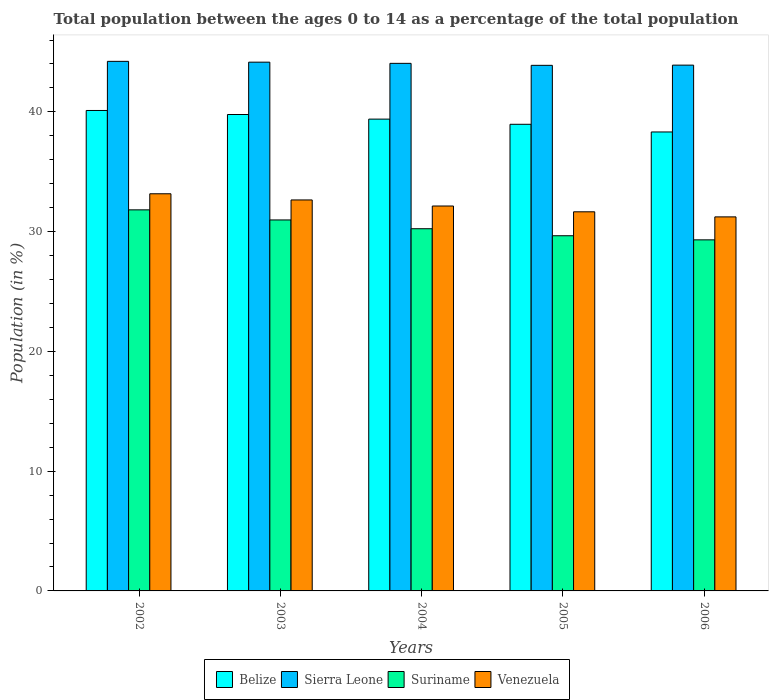How many groups of bars are there?
Give a very brief answer. 5. Are the number of bars on each tick of the X-axis equal?
Offer a very short reply. Yes. How many bars are there on the 1st tick from the right?
Ensure brevity in your answer.  4. What is the percentage of the population ages 0 to 14 in Venezuela in 2005?
Offer a very short reply. 31.66. Across all years, what is the maximum percentage of the population ages 0 to 14 in Venezuela?
Make the answer very short. 33.16. Across all years, what is the minimum percentage of the population ages 0 to 14 in Sierra Leone?
Ensure brevity in your answer.  43.89. In which year was the percentage of the population ages 0 to 14 in Venezuela maximum?
Your response must be concise. 2002. What is the total percentage of the population ages 0 to 14 in Sierra Leone in the graph?
Give a very brief answer. 220.22. What is the difference between the percentage of the population ages 0 to 14 in Sierra Leone in 2003 and that in 2004?
Give a very brief answer. 0.1. What is the difference between the percentage of the population ages 0 to 14 in Venezuela in 2003 and the percentage of the population ages 0 to 14 in Sierra Leone in 2002?
Give a very brief answer. -11.57. What is the average percentage of the population ages 0 to 14 in Suriname per year?
Make the answer very short. 30.4. In the year 2004, what is the difference between the percentage of the population ages 0 to 14 in Sierra Leone and percentage of the population ages 0 to 14 in Venezuela?
Give a very brief answer. 11.91. What is the ratio of the percentage of the population ages 0 to 14 in Venezuela in 2003 to that in 2005?
Ensure brevity in your answer.  1.03. What is the difference between the highest and the second highest percentage of the population ages 0 to 14 in Suriname?
Your answer should be compact. 0.84. What is the difference between the highest and the lowest percentage of the population ages 0 to 14 in Suriname?
Your answer should be compact. 2.5. In how many years, is the percentage of the population ages 0 to 14 in Suriname greater than the average percentage of the population ages 0 to 14 in Suriname taken over all years?
Your answer should be compact. 2. Is the sum of the percentage of the population ages 0 to 14 in Belize in 2002 and 2003 greater than the maximum percentage of the population ages 0 to 14 in Suriname across all years?
Your response must be concise. Yes. Is it the case that in every year, the sum of the percentage of the population ages 0 to 14 in Venezuela and percentage of the population ages 0 to 14 in Suriname is greater than the sum of percentage of the population ages 0 to 14 in Belize and percentage of the population ages 0 to 14 in Sierra Leone?
Offer a very short reply. No. What does the 2nd bar from the left in 2005 represents?
Offer a terse response. Sierra Leone. What does the 3rd bar from the right in 2003 represents?
Offer a very short reply. Sierra Leone. Are all the bars in the graph horizontal?
Offer a terse response. No. How many years are there in the graph?
Offer a terse response. 5. Where does the legend appear in the graph?
Provide a short and direct response. Bottom center. What is the title of the graph?
Your answer should be compact. Total population between the ages 0 to 14 as a percentage of the total population. Does "Hong Kong" appear as one of the legend labels in the graph?
Your answer should be compact. No. What is the Population (in %) in Belize in 2002?
Your answer should be very brief. 40.12. What is the Population (in %) of Sierra Leone in 2002?
Keep it short and to the point. 44.22. What is the Population (in %) of Suriname in 2002?
Your answer should be very brief. 31.82. What is the Population (in %) in Venezuela in 2002?
Your answer should be very brief. 33.16. What is the Population (in %) in Belize in 2003?
Give a very brief answer. 39.78. What is the Population (in %) in Sierra Leone in 2003?
Make the answer very short. 44.15. What is the Population (in %) in Suriname in 2003?
Make the answer very short. 30.98. What is the Population (in %) of Venezuela in 2003?
Provide a short and direct response. 32.65. What is the Population (in %) in Belize in 2004?
Provide a short and direct response. 39.4. What is the Population (in %) of Sierra Leone in 2004?
Ensure brevity in your answer.  44.05. What is the Population (in %) in Suriname in 2004?
Provide a succinct answer. 30.24. What is the Population (in %) of Venezuela in 2004?
Your answer should be compact. 32.14. What is the Population (in %) of Belize in 2005?
Give a very brief answer. 38.97. What is the Population (in %) of Sierra Leone in 2005?
Offer a very short reply. 43.89. What is the Population (in %) of Suriname in 2005?
Keep it short and to the point. 29.66. What is the Population (in %) of Venezuela in 2005?
Ensure brevity in your answer.  31.66. What is the Population (in %) in Belize in 2006?
Your answer should be compact. 38.32. What is the Population (in %) in Sierra Leone in 2006?
Provide a short and direct response. 43.9. What is the Population (in %) of Suriname in 2006?
Ensure brevity in your answer.  29.32. What is the Population (in %) of Venezuela in 2006?
Your answer should be compact. 31.23. Across all years, what is the maximum Population (in %) of Belize?
Your answer should be very brief. 40.12. Across all years, what is the maximum Population (in %) of Sierra Leone?
Your response must be concise. 44.22. Across all years, what is the maximum Population (in %) of Suriname?
Your response must be concise. 31.82. Across all years, what is the maximum Population (in %) of Venezuela?
Offer a terse response. 33.16. Across all years, what is the minimum Population (in %) in Belize?
Keep it short and to the point. 38.32. Across all years, what is the minimum Population (in %) in Sierra Leone?
Offer a terse response. 43.89. Across all years, what is the minimum Population (in %) in Suriname?
Your answer should be very brief. 29.32. Across all years, what is the minimum Population (in %) of Venezuela?
Offer a very short reply. 31.23. What is the total Population (in %) in Belize in the graph?
Make the answer very short. 196.59. What is the total Population (in %) of Sierra Leone in the graph?
Give a very brief answer. 220.22. What is the total Population (in %) of Suriname in the graph?
Provide a succinct answer. 152.02. What is the total Population (in %) in Venezuela in the graph?
Provide a short and direct response. 160.85. What is the difference between the Population (in %) in Belize in 2002 and that in 2003?
Provide a succinct answer. 0.34. What is the difference between the Population (in %) in Sierra Leone in 2002 and that in 2003?
Keep it short and to the point. 0.07. What is the difference between the Population (in %) in Suriname in 2002 and that in 2003?
Your answer should be compact. 0.84. What is the difference between the Population (in %) in Venezuela in 2002 and that in 2003?
Your response must be concise. 0.52. What is the difference between the Population (in %) in Belize in 2002 and that in 2004?
Keep it short and to the point. 0.72. What is the difference between the Population (in %) of Sierra Leone in 2002 and that in 2004?
Ensure brevity in your answer.  0.17. What is the difference between the Population (in %) of Suriname in 2002 and that in 2004?
Give a very brief answer. 1.58. What is the difference between the Population (in %) in Venezuela in 2002 and that in 2004?
Your answer should be very brief. 1.02. What is the difference between the Population (in %) in Belize in 2002 and that in 2005?
Your response must be concise. 1.15. What is the difference between the Population (in %) of Sierra Leone in 2002 and that in 2005?
Provide a succinct answer. 0.33. What is the difference between the Population (in %) in Suriname in 2002 and that in 2005?
Offer a very short reply. 2.16. What is the difference between the Population (in %) in Venezuela in 2002 and that in 2005?
Ensure brevity in your answer.  1.51. What is the difference between the Population (in %) of Belize in 2002 and that in 2006?
Your answer should be compact. 1.79. What is the difference between the Population (in %) of Sierra Leone in 2002 and that in 2006?
Offer a terse response. 0.32. What is the difference between the Population (in %) of Suriname in 2002 and that in 2006?
Provide a succinct answer. 2.5. What is the difference between the Population (in %) of Venezuela in 2002 and that in 2006?
Your response must be concise. 1.93. What is the difference between the Population (in %) of Belize in 2003 and that in 2004?
Provide a succinct answer. 0.39. What is the difference between the Population (in %) in Sierra Leone in 2003 and that in 2004?
Offer a very short reply. 0.1. What is the difference between the Population (in %) of Suriname in 2003 and that in 2004?
Ensure brevity in your answer.  0.73. What is the difference between the Population (in %) in Venezuela in 2003 and that in 2004?
Keep it short and to the point. 0.51. What is the difference between the Population (in %) of Belize in 2003 and that in 2005?
Your answer should be compact. 0.82. What is the difference between the Population (in %) of Sierra Leone in 2003 and that in 2005?
Provide a short and direct response. 0.26. What is the difference between the Population (in %) of Suriname in 2003 and that in 2005?
Ensure brevity in your answer.  1.32. What is the difference between the Population (in %) of Venezuela in 2003 and that in 2005?
Your response must be concise. 0.99. What is the difference between the Population (in %) in Belize in 2003 and that in 2006?
Give a very brief answer. 1.46. What is the difference between the Population (in %) of Sierra Leone in 2003 and that in 2006?
Make the answer very short. 0.25. What is the difference between the Population (in %) in Suriname in 2003 and that in 2006?
Make the answer very short. 1.66. What is the difference between the Population (in %) in Venezuela in 2003 and that in 2006?
Your answer should be very brief. 1.41. What is the difference between the Population (in %) in Belize in 2004 and that in 2005?
Your answer should be very brief. 0.43. What is the difference between the Population (in %) of Sierra Leone in 2004 and that in 2005?
Make the answer very short. 0.17. What is the difference between the Population (in %) in Suriname in 2004 and that in 2005?
Offer a terse response. 0.59. What is the difference between the Population (in %) in Venezuela in 2004 and that in 2005?
Keep it short and to the point. 0.48. What is the difference between the Population (in %) in Belize in 2004 and that in 2006?
Your answer should be very brief. 1.07. What is the difference between the Population (in %) of Sierra Leone in 2004 and that in 2006?
Offer a terse response. 0.15. What is the difference between the Population (in %) in Suriname in 2004 and that in 2006?
Ensure brevity in your answer.  0.93. What is the difference between the Population (in %) of Venezuela in 2004 and that in 2006?
Offer a very short reply. 0.91. What is the difference between the Population (in %) in Belize in 2005 and that in 2006?
Provide a short and direct response. 0.64. What is the difference between the Population (in %) in Sierra Leone in 2005 and that in 2006?
Give a very brief answer. -0.02. What is the difference between the Population (in %) in Suriname in 2005 and that in 2006?
Provide a succinct answer. 0.34. What is the difference between the Population (in %) of Venezuela in 2005 and that in 2006?
Offer a very short reply. 0.42. What is the difference between the Population (in %) of Belize in 2002 and the Population (in %) of Sierra Leone in 2003?
Offer a very short reply. -4.03. What is the difference between the Population (in %) in Belize in 2002 and the Population (in %) in Suriname in 2003?
Provide a short and direct response. 9.14. What is the difference between the Population (in %) of Belize in 2002 and the Population (in %) of Venezuela in 2003?
Make the answer very short. 7.47. What is the difference between the Population (in %) of Sierra Leone in 2002 and the Population (in %) of Suriname in 2003?
Your response must be concise. 13.24. What is the difference between the Population (in %) of Sierra Leone in 2002 and the Population (in %) of Venezuela in 2003?
Offer a terse response. 11.57. What is the difference between the Population (in %) in Suriname in 2002 and the Population (in %) in Venezuela in 2003?
Offer a very short reply. -0.83. What is the difference between the Population (in %) of Belize in 2002 and the Population (in %) of Sierra Leone in 2004?
Provide a short and direct response. -3.93. What is the difference between the Population (in %) of Belize in 2002 and the Population (in %) of Suriname in 2004?
Your answer should be compact. 9.87. What is the difference between the Population (in %) in Belize in 2002 and the Population (in %) in Venezuela in 2004?
Give a very brief answer. 7.98. What is the difference between the Population (in %) in Sierra Leone in 2002 and the Population (in %) in Suriname in 2004?
Your answer should be very brief. 13.98. What is the difference between the Population (in %) of Sierra Leone in 2002 and the Population (in %) of Venezuela in 2004?
Offer a very short reply. 12.08. What is the difference between the Population (in %) in Suriname in 2002 and the Population (in %) in Venezuela in 2004?
Give a very brief answer. -0.32. What is the difference between the Population (in %) in Belize in 2002 and the Population (in %) in Sierra Leone in 2005?
Provide a succinct answer. -3.77. What is the difference between the Population (in %) in Belize in 2002 and the Population (in %) in Suriname in 2005?
Your answer should be very brief. 10.46. What is the difference between the Population (in %) in Belize in 2002 and the Population (in %) in Venezuela in 2005?
Give a very brief answer. 8.46. What is the difference between the Population (in %) of Sierra Leone in 2002 and the Population (in %) of Suriname in 2005?
Ensure brevity in your answer.  14.56. What is the difference between the Population (in %) of Sierra Leone in 2002 and the Population (in %) of Venezuela in 2005?
Your response must be concise. 12.56. What is the difference between the Population (in %) in Suriname in 2002 and the Population (in %) in Venezuela in 2005?
Make the answer very short. 0.16. What is the difference between the Population (in %) in Belize in 2002 and the Population (in %) in Sierra Leone in 2006?
Keep it short and to the point. -3.79. What is the difference between the Population (in %) of Belize in 2002 and the Population (in %) of Suriname in 2006?
Your response must be concise. 10.8. What is the difference between the Population (in %) in Belize in 2002 and the Population (in %) in Venezuela in 2006?
Provide a short and direct response. 8.89. What is the difference between the Population (in %) of Sierra Leone in 2002 and the Population (in %) of Suriname in 2006?
Your response must be concise. 14.9. What is the difference between the Population (in %) of Sierra Leone in 2002 and the Population (in %) of Venezuela in 2006?
Keep it short and to the point. 12.99. What is the difference between the Population (in %) of Suriname in 2002 and the Population (in %) of Venezuela in 2006?
Offer a terse response. 0.59. What is the difference between the Population (in %) of Belize in 2003 and the Population (in %) of Sierra Leone in 2004?
Provide a short and direct response. -4.27. What is the difference between the Population (in %) in Belize in 2003 and the Population (in %) in Suriname in 2004?
Give a very brief answer. 9.54. What is the difference between the Population (in %) of Belize in 2003 and the Population (in %) of Venezuela in 2004?
Offer a terse response. 7.64. What is the difference between the Population (in %) of Sierra Leone in 2003 and the Population (in %) of Suriname in 2004?
Keep it short and to the point. 13.91. What is the difference between the Population (in %) in Sierra Leone in 2003 and the Population (in %) in Venezuela in 2004?
Your answer should be very brief. 12.01. What is the difference between the Population (in %) in Suriname in 2003 and the Population (in %) in Venezuela in 2004?
Offer a terse response. -1.16. What is the difference between the Population (in %) in Belize in 2003 and the Population (in %) in Sierra Leone in 2005?
Your answer should be compact. -4.11. What is the difference between the Population (in %) of Belize in 2003 and the Population (in %) of Suriname in 2005?
Your answer should be compact. 10.12. What is the difference between the Population (in %) in Belize in 2003 and the Population (in %) in Venezuela in 2005?
Ensure brevity in your answer.  8.12. What is the difference between the Population (in %) in Sierra Leone in 2003 and the Population (in %) in Suriname in 2005?
Your answer should be very brief. 14.49. What is the difference between the Population (in %) of Sierra Leone in 2003 and the Population (in %) of Venezuela in 2005?
Provide a succinct answer. 12.5. What is the difference between the Population (in %) of Suriname in 2003 and the Population (in %) of Venezuela in 2005?
Provide a succinct answer. -0.68. What is the difference between the Population (in %) of Belize in 2003 and the Population (in %) of Sierra Leone in 2006?
Give a very brief answer. -4.12. What is the difference between the Population (in %) of Belize in 2003 and the Population (in %) of Suriname in 2006?
Make the answer very short. 10.47. What is the difference between the Population (in %) of Belize in 2003 and the Population (in %) of Venezuela in 2006?
Your response must be concise. 8.55. What is the difference between the Population (in %) in Sierra Leone in 2003 and the Population (in %) in Suriname in 2006?
Your response must be concise. 14.84. What is the difference between the Population (in %) of Sierra Leone in 2003 and the Population (in %) of Venezuela in 2006?
Your answer should be very brief. 12.92. What is the difference between the Population (in %) in Suriname in 2003 and the Population (in %) in Venezuela in 2006?
Offer a very short reply. -0.26. What is the difference between the Population (in %) of Belize in 2004 and the Population (in %) of Sierra Leone in 2005?
Keep it short and to the point. -4.49. What is the difference between the Population (in %) in Belize in 2004 and the Population (in %) in Suriname in 2005?
Provide a short and direct response. 9.74. What is the difference between the Population (in %) in Belize in 2004 and the Population (in %) in Venezuela in 2005?
Offer a very short reply. 7.74. What is the difference between the Population (in %) in Sierra Leone in 2004 and the Population (in %) in Suriname in 2005?
Your answer should be very brief. 14.39. What is the difference between the Population (in %) of Sierra Leone in 2004 and the Population (in %) of Venezuela in 2005?
Your answer should be compact. 12.4. What is the difference between the Population (in %) in Suriname in 2004 and the Population (in %) in Venezuela in 2005?
Provide a short and direct response. -1.41. What is the difference between the Population (in %) in Belize in 2004 and the Population (in %) in Sierra Leone in 2006?
Offer a very short reply. -4.51. What is the difference between the Population (in %) in Belize in 2004 and the Population (in %) in Suriname in 2006?
Offer a very short reply. 10.08. What is the difference between the Population (in %) in Belize in 2004 and the Population (in %) in Venezuela in 2006?
Keep it short and to the point. 8.16. What is the difference between the Population (in %) in Sierra Leone in 2004 and the Population (in %) in Suriname in 2006?
Provide a succinct answer. 14.74. What is the difference between the Population (in %) of Sierra Leone in 2004 and the Population (in %) of Venezuela in 2006?
Give a very brief answer. 12.82. What is the difference between the Population (in %) of Suriname in 2004 and the Population (in %) of Venezuela in 2006?
Provide a succinct answer. -0.99. What is the difference between the Population (in %) in Belize in 2005 and the Population (in %) in Sierra Leone in 2006?
Ensure brevity in your answer.  -4.94. What is the difference between the Population (in %) in Belize in 2005 and the Population (in %) in Suriname in 2006?
Ensure brevity in your answer.  9.65. What is the difference between the Population (in %) of Belize in 2005 and the Population (in %) of Venezuela in 2006?
Your answer should be compact. 7.73. What is the difference between the Population (in %) of Sierra Leone in 2005 and the Population (in %) of Suriname in 2006?
Provide a short and direct response. 14.57. What is the difference between the Population (in %) in Sierra Leone in 2005 and the Population (in %) in Venezuela in 2006?
Give a very brief answer. 12.66. What is the difference between the Population (in %) in Suriname in 2005 and the Population (in %) in Venezuela in 2006?
Your response must be concise. -1.57. What is the average Population (in %) in Belize per year?
Provide a succinct answer. 39.32. What is the average Population (in %) of Sierra Leone per year?
Your answer should be very brief. 44.04. What is the average Population (in %) of Suriname per year?
Keep it short and to the point. 30.4. What is the average Population (in %) in Venezuela per year?
Offer a very short reply. 32.17. In the year 2002, what is the difference between the Population (in %) in Belize and Population (in %) in Sierra Leone?
Ensure brevity in your answer.  -4.1. In the year 2002, what is the difference between the Population (in %) in Belize and Population (in %) in Suriname?
Your answer should be very brief. 8.3. In the year 2002, what is the difference between the Population (in %) in Belize and Population (in %) in Venezuela?
Your response must be concise. 6.96. In the year 2002, what is the difference between the Population (in %) of Sierra Leone and Population (in %) of Suriname?
Your answer should be very brief. 12.4. In the year 2002, what is the difference between the Population (in %) of Sierra Leone and Population (in %) of Venezuela?
Your answer should be very brief. 11.06. In the year 2002, what is the difference between the Population (in %) in Suriname and Population (in %) in Venezuela?
Keep it short and to the point. -1.34. In the year 2003, what is the difference between the Population (in %) of Belize and Population (in %) of Sierra Leone?
Provide a short and direct response. -4.37. In the year 2003, what is the difference between the Population (in %) of Belize and Population (in %) of Suriname?
Offer a very short reply. 8.8. In the year 2003, what is the difference between the Population (in %) in Belize and Population (in %) in Venezuela?
Offer a very short reply. 7.13. In the year 2003, what is the difference between the Population (in %) in Sierra Leone and Population (in %) in Suriname?
Offer a very short reply. 13.18. In the year 2003, what is the difference between the Population (in %) in Sierra Leone and Population (in %) in Venezuela?
Your answer should be compact. 11.51. In the year 2003, what is the difference between the Population (in %) of Suriname and Population (in %) of Venezuela?
Your response must be concise. -1.67. In the year 2004, what is the difference between the Population (in %) in Belize and Population (in %) in Sierra Leone?
Your answer should be very brief. -4.66. In the year 2004, what is the difference between the Population (in %) of Belize and Population (in %) of Suriname?
Offer a terse response. 9.15. In the year 2004, what is the difference between the Population (in %) of Belize and Population (in %) of Venezuela?
Your answer should be compact. 7.25. In the year 2004, what is the difference between the Population (in %) of Sierra Leone and Population (in %) of Suriname?
Provide a short and direct response. 13.81. In the year 2004, what is the difference between the Population (in %) in Sierra Leone and Population (in %) in Venezuela?
Offer a very short reply. 11.91. In the year 2004, what is the difference between the Population (in %) in Suriname and Population (in %) in Venezuela?
Give a very brief answer. -1.9. In the year 2005, what is the difference between the Population (in %) in Belize and Population (in %) in Sierra Leone?
Provide a short and direct response. -4.92. In the year 2005, what is the difference between the Population (in %) of Belize and Population (in %) of Suriname?
Your answer should be very brief. 9.31. In the year 2005, what is the difference between the Population (in %) in Belize and Population (in %) in Venezuela?
Make the answer very short. 7.31. In the year 2005, what is the difference between the Population (in %) in Sierra Leone and Population (in %) in Suriname?
Offer a terse response. 14.23. In the year 2005, what is the difference between the Population (in %) in Sierra Leone and Population (in %) in Venezuela?
Provide a succinct answer. 12.23. In the year 2005, what is the difference between the Population (in %) of Suriname and Population (in %) of Venezuela?
Provide a short and direct response. -2. In the year 2006, what is the difference between the Population (in %) in Belize and Population (in %) in Sierra Leone?
Offer a very short reply. -5.58. In the year 2006, what is the difference between the Population (in %) of Belize and Population (in %) of Suriname?
Offer a very short reply. 9.01. In the year 2006, what is the difference between the Population (in %) of Belize and Population (in %) of Venezuela?
Your response must be concise. 7.09. In the year 2006, what is the difference between the Population (in %) in Sierra Leone and Population (in %) in Suriname?
Your answer should be compact. 14.59. In the year 2006, what is the difference between the Population (in %) of Sierra Leone and Population (in %) of Venezuela?
Your response must be concise. 12.67. In the year 2006, what is the difference between the Population (in %) of Suriname and Population (in %) of Venezuela?
Your answer should be very brief. -1.92. What is the ratio of the Population (in %) in Belize in 2002 to that in 2003?
Provide a succinct answer. 1.01. What is the ratio of the Population (in %) in Suriname in 2002 to that in 2003?
Provide a succinct answer. 1.03. What is the ratio of the Population (in %) of Venezuela in 2002 to that in 2003?
Offer a very short reply. 1.02. What is the ratio of the Population (in %) in Belize in 2002 to that in 2004?
Make the answer very short. 1.02. What is the ratio of the Population (in %) of Suriname in 2002 to that in 2004?
Your answer should be compact. 1.05. What is the ratio of the Population (in %) in Venezuela in 2002 to that in 2004?
Ensure brevity in your answer.  1.03. What is the ratio of the Population (in %) in Belize in 2002 to that in 2005?
Keep it short and to the point. 1.03. What is the ratio of the Population (in %) in Sierra Leone in 2002 to that in 2005?
Provide a succinct answer. 1.01. What is the ratio of the Population (in %) of Suriname in 2002 to that in 2005?
Your answer should be compact. 1.07. What is the ratio of the Population (in %) of Venezuela in 2002 to that in 2005?
Give a very brief answer. 1.05. What is the ratio of the Population (in %) of Belize in 2002 to that in 2006?
Keep it short and to the point. 1.05. What is the ratio of the Population (in %) in Suriname in 2002 to that in 2006?
Provide a short and direct response. 1.09. What is the ratio of the Population (in %) of Venezuela in 2002 to that in 2006?
Offer a terse response. 1.06. What is the ratio of the Population (in %) in Belize in 2003 to that in 2004?
Your answer should be compact. 1.01. What is the ratio of the Population (in %) in Suriname in 2003 to that in 2004?
Make the answer very short. 1.02. What is the ratio of the Population (in %) of Venezuela in 2003 to that in 2004?
Make the answer very short. 1.02. What is the ratio of the Population (in %) in Sierra Leone in 2003 to that in 2005?
Give a very brief answer. 1.01. What is the ratio of the Population (in %) in Suriname in 2003 to that in 2005?
Make the answer very short. 1.04. What is the ratio of the Population (in %) in Venezuela in 2003 to that in 2005?
Your answer should be very brief. 1.03. What is the ratio of the Population (in %) of Belize in 2003 to that in 2006?
Your answer should be very brief. 1.04. What is the ratio of the Population (in %) of Sierra Leone in 2003 to that in 2006?
Keep it short and to the point. 1.01. What is the ratio of the Population (in %) in Suriname in 2003 to that in 2006?
Offer a very short reply. 1.06. What is the ratio of the Population (in %) of Venezuela in 2003 to that in 2006?
Your answer should be compact. 1.05. What is the ratio of the Population (in %) in Belize in 2004 to that in 2005?
Your answer should be compact. 1.01. What is the ratio of the Population (in %) of Sierra Leone in 2004 to that in 2005?
Provide a short and direct response. 1. What is the ratio of the Population (in %) of Suriname in 2004 to that in 2005?
Provide a succinct answer. 1.02. What is the ratio of the Population (in %) in Venezuela in 2004 to that in 2005?
Provide a short and direct response. 1.02. What is the ratio of the Population (in %) in Belize in 2004 to that in 2006?
Your answer should be very brief. 1.03. What is the ratio of the Population (in %) in Sierra Leone in 2004 to that in 2006?
Your answer should be very brief. 1. What is the ratio of the Population (in %) in Suriname in 2004 to that in 2006?
Ensure brevity in your answer.  1.03. What is the ratio of the Population (in %) of Venezuela in 2004 to that in 2006?
Ensure brevity in your answer.  1.03. What is the ratio of the Population (in %) in Belize in 2005 to that in 2006?
Keep it short and to the point. 1.02. What is the ratio of the Population (in %) of Sierra Leone in 2005 to that in 2006?
Your answer should be very brief. 1. What is the ratio of the Population (in %) of Suriname in 2005 to that in 2006?
Ensure brevity in your answer.  1.01. What is the ratio of the Population (in %) of Venezuela in 2005 to that in 2006?
Your response must be concise. 1.01. What is the difference between the highest and the second highest Population (in %) in Belize?
Your answer should be compact. 0.34. What is the difference between the highest and the second highest Population (in %) of Sierra Leone?
Provide a succinct answer. 0.07. What is the difference between the highest and the second highest Population (in %) in Suriname?
Your answer should be very brief. 0.84. What is the difference between the highest and the second highest Population (in %) in Venezuela?
Your answer should be very brief. 0.52. What is the difference between the highest and the lowest Population (in %) of Belize?
Your answer should be compact. 1.79. What is the difference between the highest and the lowest Population (in %) of Sierra Leone?
Ensure brevity in your answer.  0.33. What is the difference between the highest and the lowest Population (in %) of Suriname?
Your answer should be compact. 2.5. What is the difference between the highest and the lowest Population (in %) in Venezuela?
Your answer should be compact. 1.93. 